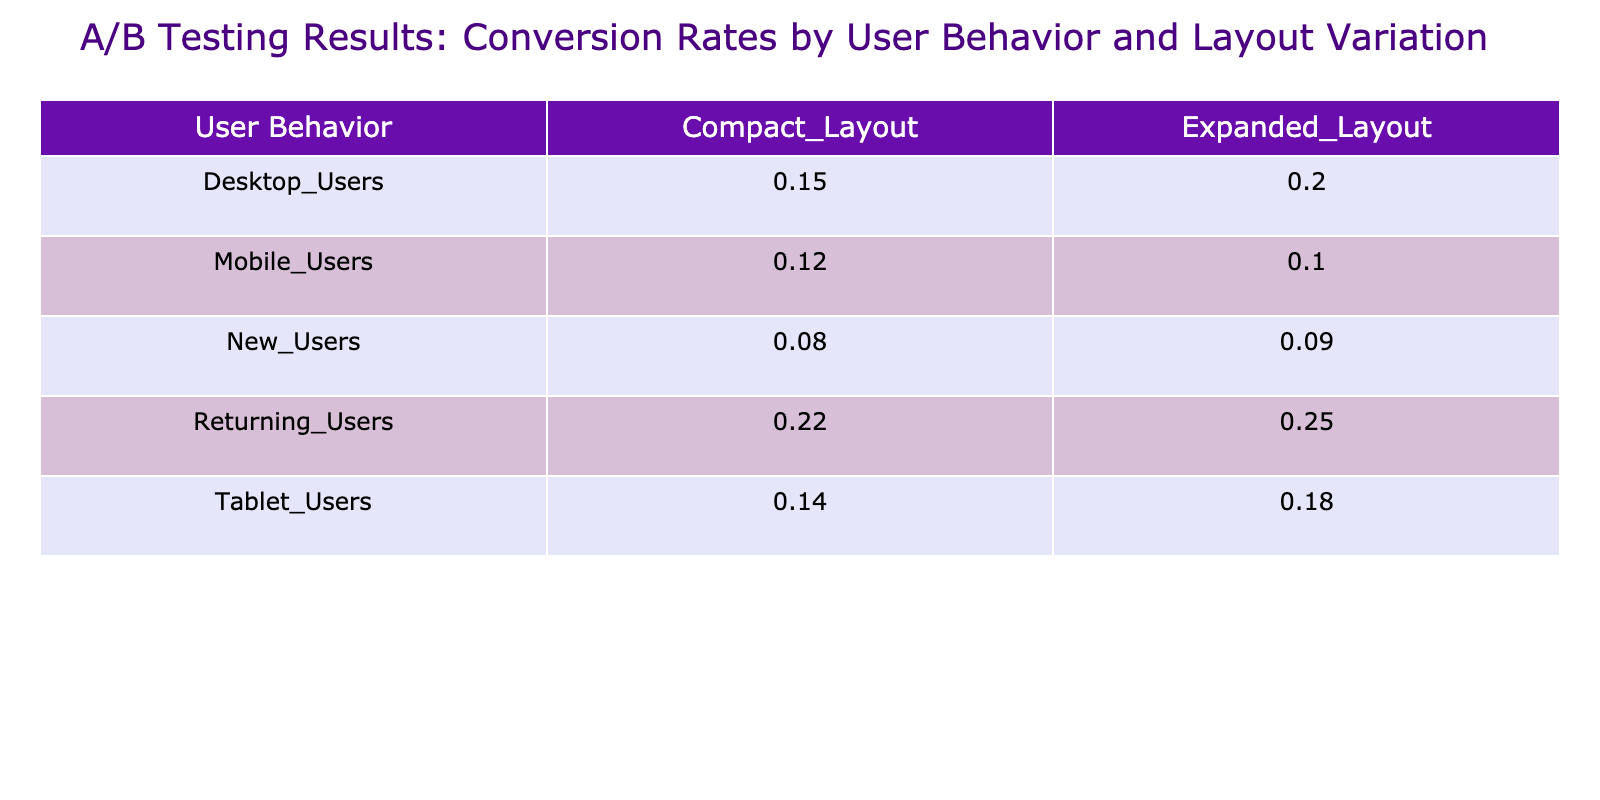What is the conversion rate for Mobile Users with the Compact Layout? The table shows that for Mobile Users and the Compact Layout, the Conversion Rate is 0.12 as found in the corresponding cell of the pivot table.
Answer: 0.12 Which layout variation had the highest conversion rate for Desktop Users? By comparing the conversion rates for Desktop Users in both layout variations, the Expanded Layout has a conversion rate of 0.20, while the Compact Layout has 0.15. Thus, Expanded Layout has the highest conversion rate.
Answer: Expanded Layout What is the average conversion rate for all layout variations among Tablet Users? The conversion rates for Tablet Users are 0.14 for Compact Layout and 0.18 for Expanded Layout. To find the average, we add them (0.14 + 0.18 = 0.32) and divide by 2, giving us 0.32 / 2 = 0.16.
Answer: 0.16 Is the conversion rate for Returning Users higher with the Compact Layout than with the Expanded Layout? Returning Users show a conversion rate of 0.22 with the Compact Layout and 0.25 with the Expanded Layout. Since 0.22 is less than 0.25, the answer is no.
Answer: No What is the difference in conversion rates between New Users for the Compact and Expanded Layouts? The conversion rate for New Users with the Compact Layout is 0.08, while for the Expanded Layout, it is 0.09. The difference is calculated as 0.09 - 0.08 = 0.01.
Answer: 0.01 For which user behavior does the Compact Layout have the lowest conversion rate? The Compact Layout's conversion rates are 0.12 (Mobile), 0.15 (Desktop), 0.14 (Tablet), 0.22 (Returning), and 0.08 (New). Thus, 0.08 for New Users is the lowest rate.
Answer: New Users Which user behavior group experienced the highest number of Page Views with the Compact Layout? Looking at the Page Views for the Compact Layout: Mobile Users have 1500, Desktop Users have 2000, Tablet Users have 1200, Returning Users have 800, and New Users have 1000. Desktop Users had the highest with 2000.
Answer: Desktop Users Does the Expanded Layout have a higher average conversion rate than the Compact Layout across all groups? The conversion rates for Expanded Layouts are 0.10 (Mobile), 0.20 (Desktop), 0.18 (Tablet), 0.25 (Returning), and 0.09 (New). The average for Expanded Layouts is (0.10 + 0.20 + 0.18 + 0.25 + 0.09) / 5 = 0.164. For Compact Layouts: (0.12 + 0.15 + 0.14 + 0.22 + 0.08) / 5 = 0.142. Since 0.164 is greater than 0.142, the answer is yes.
Answer: Yes 